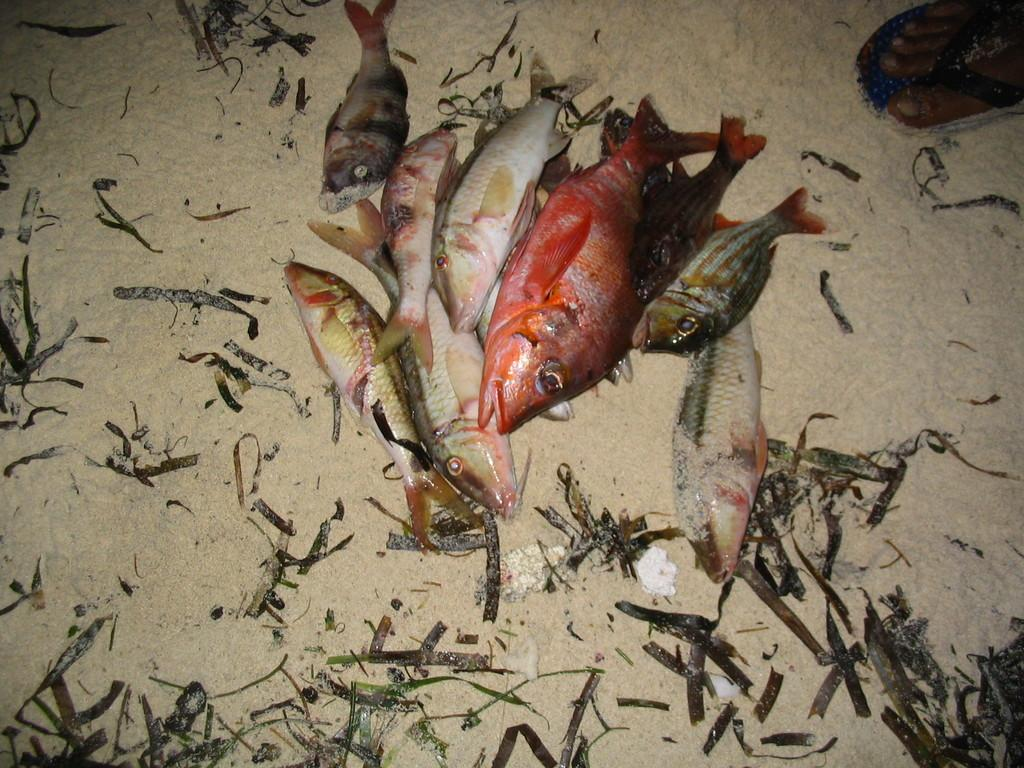What type of animals can be seen in the image? There are fish in the image. What can be found on the ground in the image? There are leaves on the ground in the image. Can you describe any part of a person visible in the image? A human leg is visible in the top right corner of the image. What news is being reported by the crowd in the image? There is no crowd present in the image, so no news is being reported. 